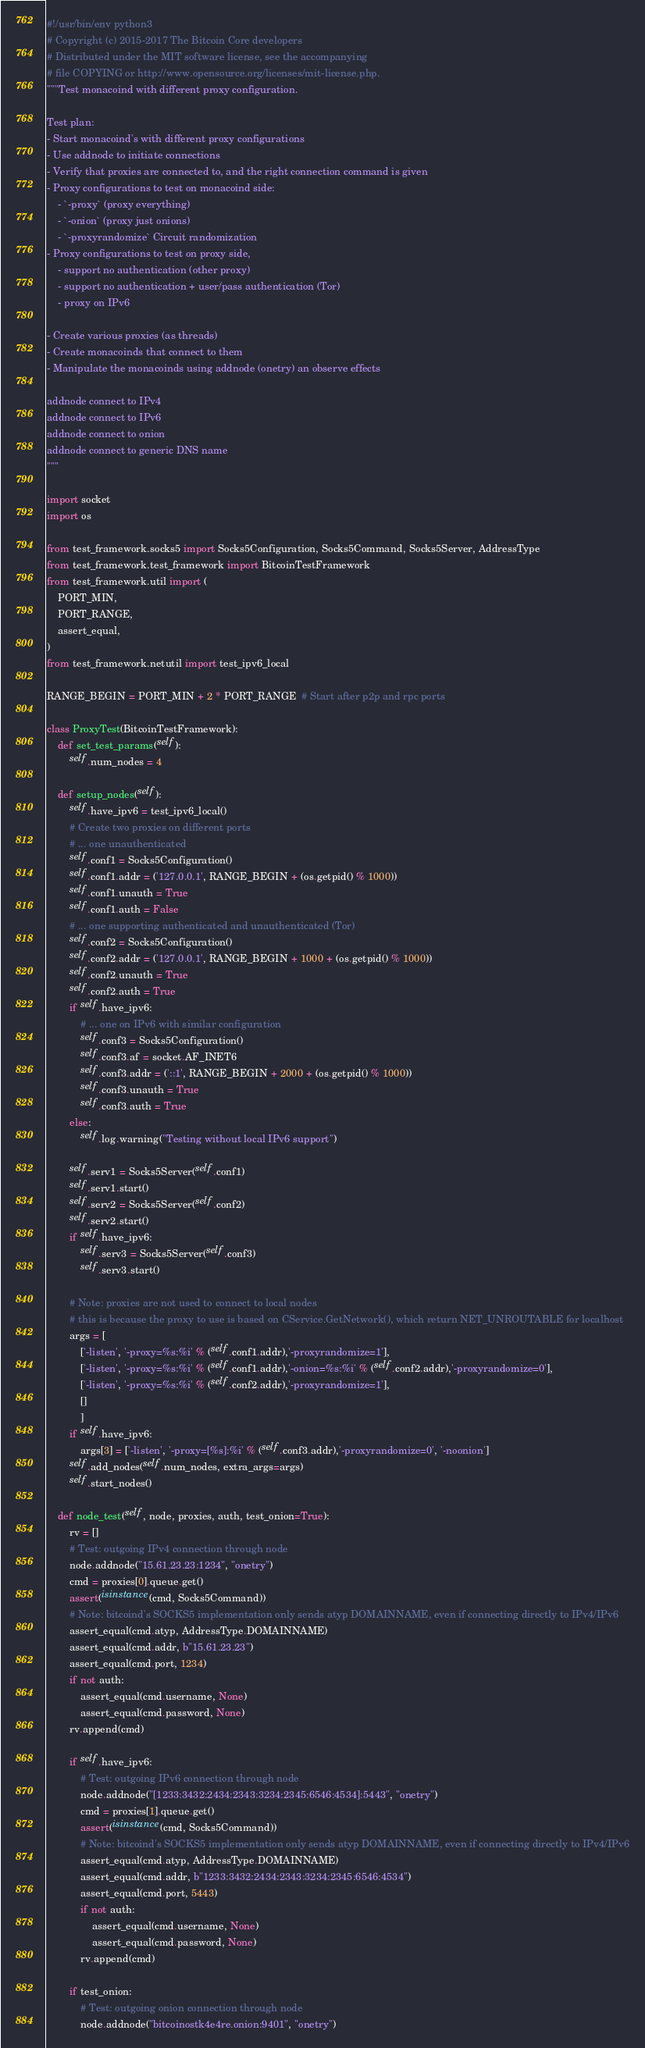Convert code to text. <code><loc_0><loc_0><loc_500><loc_500><_Python_>#!/usr/bin/env python3
# Copyright (c) 2015-2017 The Bitcoin Core developers
# Distributed under the MIT software license, see the accompanying
# file COPYING or http://www.opensource.org/licenses/mit-license.php.
"""Test monacoind with different proxy configuration.

Test plan:
- Start monacoind's with different proxy configurations
- Use addnode to initiate connections
- Verify that proxies are connected to, and the right connection command is given
- Proxy configurations to test on monacoind side:
    - `-proxy` (proxy everything)
    - `-onion` (proxy just onions)
    - `-proxyrandomize` Circuit randomization
- Proxy configurations to test on proxy side,
    - support no authentication (other proxy)
    - support no authentication + user/pass authentication (Tor)
    - proxy on IPv6

- Create various proxies (as threads)
- Create monacoinds that connect to them
- Manipulate the monacoinds using addnode (onetry) an observe effects

addnode connect to IPv4
addnode connect to IPv6
addnode connect to onion
addnode connect to generic DNS name
"""

import socket
import os

from test_framework.socks5 import Socks5Configuration, Socks5Command, Socks5Server, AddressType
from test_framework.test_framework import BitcoinTestFramework
from test_framework.util import (
    PORT_MIN,
    PORT_RANGE,
    assert_equal,
)
from test_framework.netutil import test_ipv6_local

RANGE_BEGIN = PORT_MIN + 2 * PORT_RANGE  # Start after p2p and rpc ports

class ProxyTest(BitcoinTestFramework):
    def set_test_params(self):
        self.num_nodes = 4

    def setup_nodes(self):
        self.have_ipv6 = test_ipv6_local()
        # Create two proxies on different ports
        # ... one unauthenticated
        self.conf1 = Socks5Configuration()
        self.conf1.addr = ('127.0.0.1', RANGE_BEGIN + (os.getpid() % 1000))
        self.conf1.unauth = True
        self.conf1.auth = False
        # ... one supporting authenticated and unauthenticated (Tor)
        self.conf2 = Socks5Configuration()
        self.conf2.addr = ('127.0.0.1', RANGE_BEGIN + 1000 + (os.getpid() % 1000))
        self.conf2.unauth = True
        self.conf2.auth = True
        if self.have_ipv6:
            # ... one on IPv6 with similar configuration
            self.conf3 = Socks5Configuration()
            self.conf3.af = socket.AF_INET6
            self.conf3.addr = ('::1', RANGE_BEGIN + 2000 + (os.getpid() % 1000))
            self.conf3.unauth = True
            self.conf3.auth = True
        else:
            self.log.warning("Testing without local IPv6 support")

        self.serv1 = Socks5Server(self.conf1)
        self.serv1.start()
        self.serv2 = Socks5Server(self.conf2)
        self.serv2.start()
        if self.have_ipv6:
            self.serv3 = Socks5Server(self.conf3)
            self.serv3.start()

        # Note: proxies are not used to connect to local nodes
        # this is because the proxy to use is based on CService.GetNetwork(), which return NET_UNROUTABLE for localhost
        args = [
            ['-listen', '-proxy=%s:%i' % (self.conf1.addr),'-proxyrandomize=1'], 
            ['-listen', '-proxy=%s:%i' % (self.conf1.addr),'-onion=%s:%i' % (self.conf2.addr),'-proxyrandomize=0'], 
            ['-listen', '-proxy=%s:%i' % (self.conf2.addr),'-proxyrandomize=1'], 
            []
            ]
        if self.have_ipv6:
            args[3] = ['-listen', '-proxy=[%s]:%i' % (self.conf3.addr),'-proxyrandomize=0', '-noonion']
        self.add_nodes(self.num_nodes, extra_args=args)
        self.start_nodes()

    def node_test(self, node, proxies, auth, test_onion=True):
        rv = []
        # Test: outgoing IPv4 connection through node
        node.addnode("15.61.23.23:1234", "onetry")
        cmd = proxies[0].queue.get()
        assert(isinstance(cmd, Socks5Command))
        # Note: bitcoind's SOCKS5 implementation only sends atyp DOMAINNAME, even if connecting directly to IPv4/IPv6
        assert_equal(cmd.atyp, AddressType.DOMAINNAME)
        assert_equal(cmd.addr, b"15.61.23.23")
        assert_equal(cmd.port, 1234)
        if not auth:
            assert_equal(cmd.username, None)
            assert_equal(cmd.password, None)
        rv.append(cmd)

        if self.have_ipv6:
            # Test: outgoing IPv6 connection through node
            node.addnode("[1233:3432:2434:2343:3234:2345:6546:4534]:5443", "onetry")
            cmd = proxies[1].queue.get()
            assert(isinstance(cmd, Socks5Command))
            # Note: bitcoind's SOCKS5 implementation only sends atyp DOMAINNAME, even if connecting directly to IPv4/IPv6
            assert_equal(cmd.atyp, AddressType.DOMAINNAME)
            assert_equal(cmd.addr, b"1233:3432:2434:2343:3234:2345:6546:4534")
            assert_equal(cmd.port, 5443)
            if not auth:
                assert_equal(cmd.username, None)
                assert_equal(cmd.password, None)
            rv.append(cmd)

        if test_onion:
            # Test: outgoing onion connection through node
            node.addnode("bitcoinostk4e4re.onion:9401", "onetry")</code> 